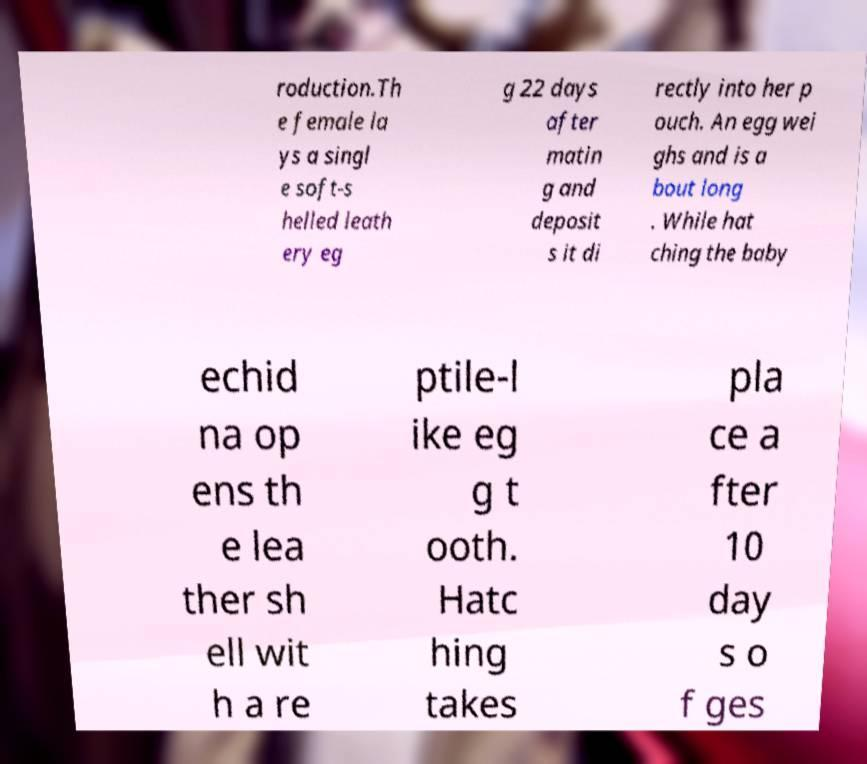There's text embedded in this image that I need extracted. Can you transcribe it verbatim? roduction.Th e female la ys a singl e soft-s helled leath ery eg g 22 days after matin g and deposit s it di rectly into her p ouch. An egg wei ghs and is a bout long . While hat ching the baby echid na op ens th e lea ther sh ell wit h a re ptile-l ike eg g t ooth. Hatc hing takes pla ce a fter 10 day s o f ges 